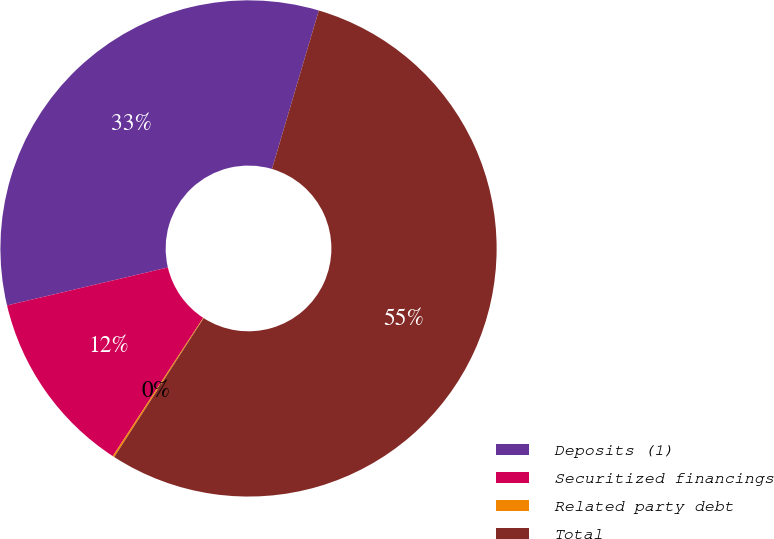Convert chart. <chart><loc_0><loc_0><loc_500><loc_500><pie_chart><fcel>Deposits (1)<fcel>Securitized financings<fcel>Related party debt<fcel>Total<nl><fcel>33.26%<fcel>12.1%<fcel>0.11%<fcel>54.53%<nl></chart> 